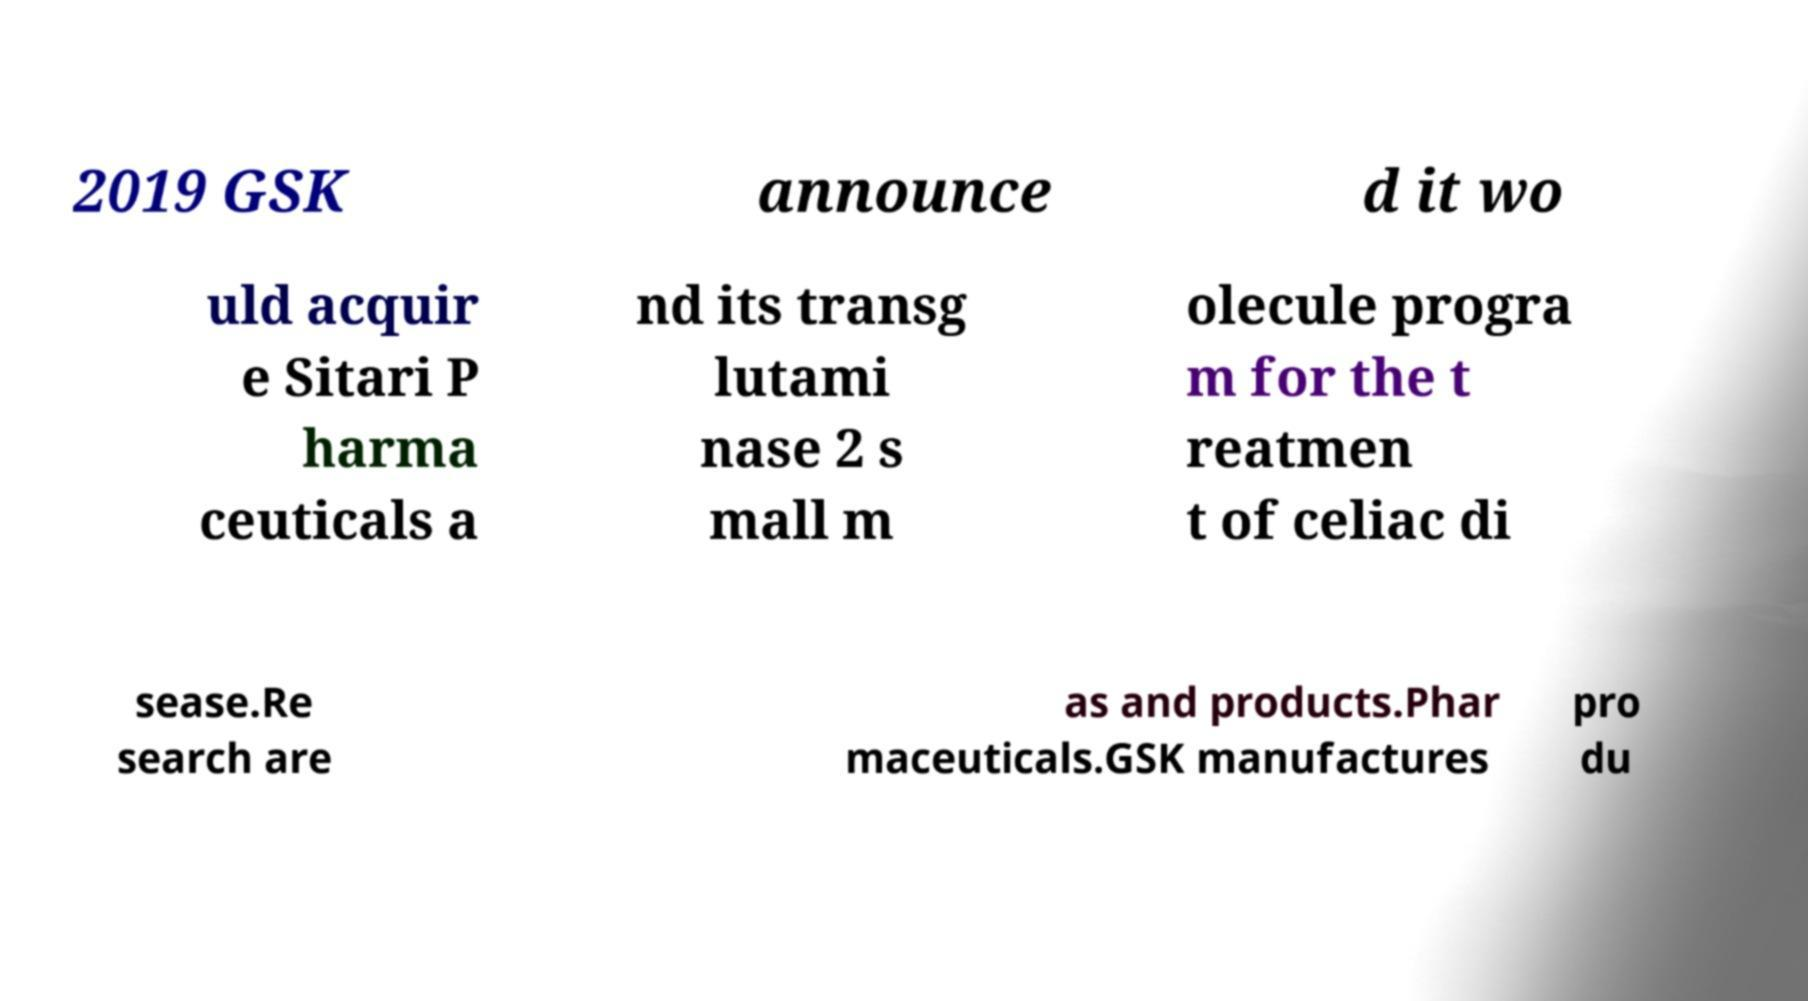I need the written content from this picture converted into text. Can you do that? 2019 GSK announce d it wo uld acquir e Sitari P harma ceuticals a nd its transg lutami nase 2 s mall m olecule progra m for the t reatmen t of celiac di sease.Re search are as and products.Phar maceuticals.GSK manufactures pro du 